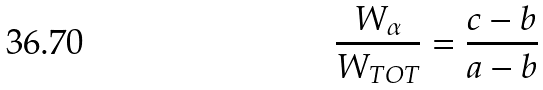<formula> <loc_0><loc_0><loc_500><loc_500>\frac { W _ { \alpha } } { W _ { T O T } } = \frac { c - b } { a - b }</formula> 